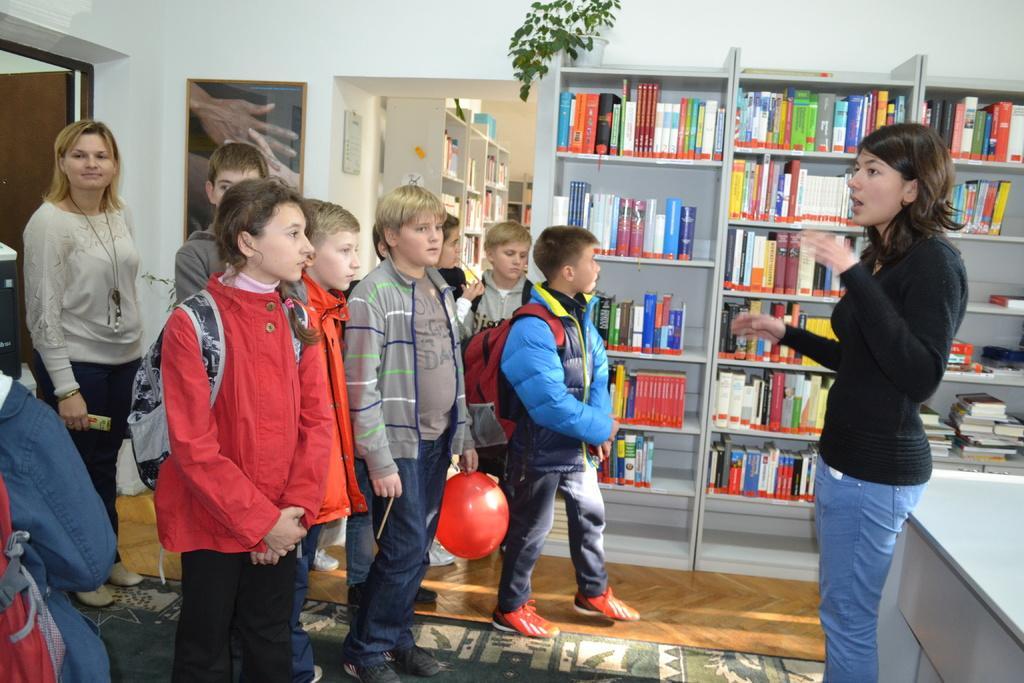In one or two sentences, can you explain what this image depicts? There are few kids standing on the floor and there are two women standing on the floor where one is on the left and the other is on the right and there are books on the bookshelves and a house plant on a rack and we can see a door on the left and there is an object on the wall and we can also see books on the bookshelves in another room and on the right at the bottom corner we can see a table. 